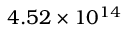<formula> <loc_0><loc_0><loc_500><loc_500>4 . 5 2 \times 1 0 ^ { 1 4 }</formula> 